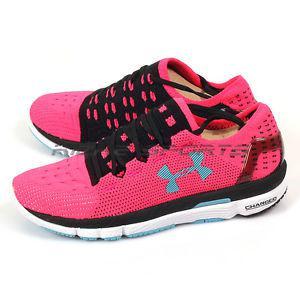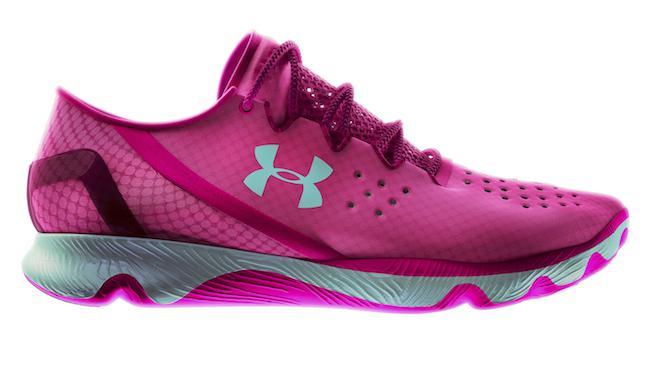The first image is the image on the left, the second image is the image on the right. Evaluate the accuracy of this statement regarding the images: "There are three total shoes in the pair.". Is it true? Answer yes or no. Yes. The first image is the image on the left, the second image is the image on the right. Assess this claim about the two images: "The matching pair of shoes faces left.". Correct or not? Answer yes or no. Yes. 